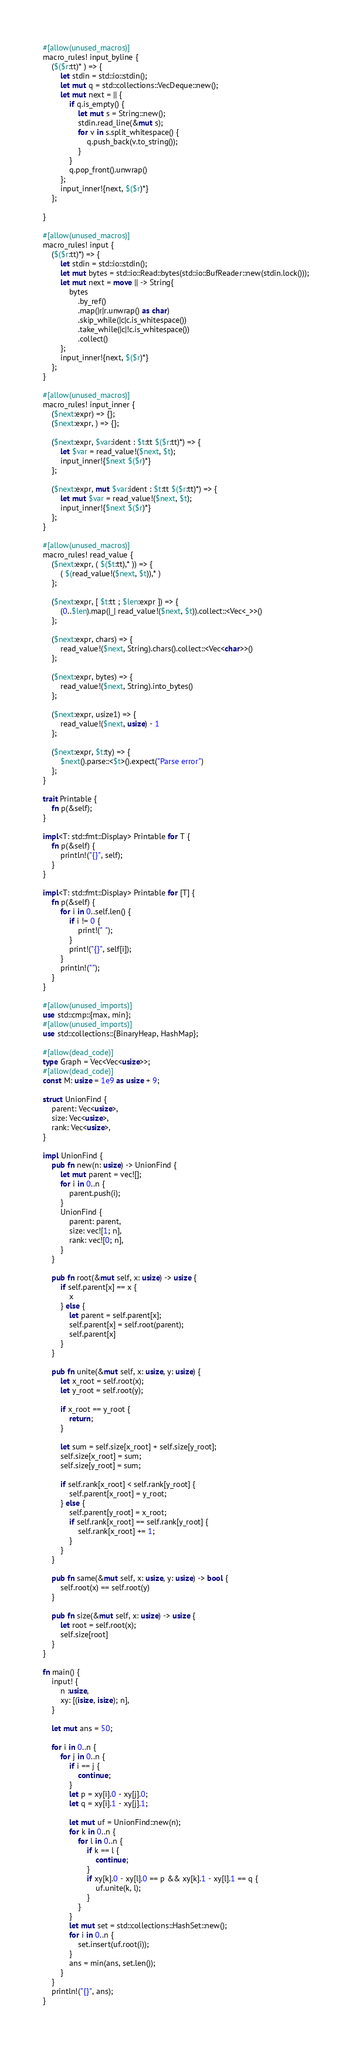<code> <loc_0><loc_0><loc_500><loc_500><_Rust_>#[allow(unused_macros)]
macro_rules! input_byline {
    ($($r:tt)* ) => {
        let stdin = std::io::stdin();
        let mut q = std::collections::VecDeque::new();
        let mut next = || {
            if q.is_empty() {
                let mut s = String::new();
                stdin.read_line(&mut s);
                for v in s.split_whitespace() {
                    q.push_back(v.to_string());
                }
            }
            q.pop_front().unwrap()
        };
        input_inner!{next, $($r)*}
    };

}

#[allow(unused_macros)]
macro_rules! input {
    ($($r:tt)*) => {
        let stdin = std::io::stdin();
        let mut bytes = std::io::Read::bytes(std::io::BufReader::new(stdin.lock()));
        let mut next = move || -> String{
            bytes
                .by_ref()
                .map(|r|r.unwrap() as char)
                .skip_while(|c|c.is_whitespace())
                .take_while(|c|!c.is_whitespace())
                .collect()
        };
        input_inner!{next, $($r)*}
    };
}

#[allow(unused_macros)]
macro_rules! input_inner {
    ($next:expr) => {};
    ($next:expr, ) => {};

    ($next:expr, $var:ident : $t:tt $($r:tt)*) => {
        let $var = read_value!($next, $t);
        input_inner!{$next $($r)*}
    };

    ($next:expr, mut $var:ident : $t:tt $($r:tt)*) => {
        let mut $var = read_value!($next, $t);
        input_inner!{$next $($r)*}
    };
}

#[allow(unused_macros)]
macro_rules! read_value {
    ($next:expr, ( $($t:tt),* )) => {
        ( $(read_value!($next, $t)),* )
    };

    ($next:expr, [ $t:tt ; $len:expr ]) => {
        (0..$len).map(|_| read_value!($next, $t)).collect::<Vec<_>>()
    };

    ($next:expr, chars) => {
        read_value!($next, String).chars().collect::<Vec<char>>()
    };

    ($next:expr, bytes) => {
        read_value!($next, String).into_bytes()
    };

    ($next:expr, usize1) => {
        read_value!($next, usize) - 1
    };

    ($next:expr, $t:ty) => {
        $next().parse::<$t>().expect("Parse error")
    };
}

trait Printable {
    fn p(&self);
}

impl<T: std::fmt::Display> Printable for T {
    fn p(&self) {
        println!("{}", self);
    }
}

impl<T: std::fmt::Display> Printable for [T] {
    fn p(&self) {
        for i in 0..self.len() {
            if i != 0 {
                print!(" ");
            }
            print!("{}", self[i]);
        }
        println!("");
    }
}

#[allow(unused_imports)]
use std::cmp::{max, min};
#[allow(unused_imports)]
use std::collections::{BinaryHeap, HashMap};

#[allow(dead_code)]
type Graph = Vec<Vec<usize>>;
#[allow(dead_code)]
const M: usize = 1e9 as usize + 9;

struct UnionFind {
    parent: Vec<usize>,
    size: Vec<usize>,
    rank: Vec<usize>,
}

impl UnionFind {
    pub fn new(n: usize) -> UnionFind {
        let mut parent = vec![];
        for i in 0..n {
            parent.push(i);
        }
        UnionFind {
            parent: parent,
            size: vec![1; n],
            rank: vec![0; n],
        }
    }

    pub fn root(&mut self, x: usize) -> usize {
        if self.parent[x] == x {
            x
        } else {
            let parent = self.parent[x];
            self.parent[x] = self.root(parent);
            self.parent[x]
        }
    }

    pub fn unite(&mut self, x: usize, y: usize) {
        let x_root = self.root(x);
        let y_root = self.root(y);

        if x_root == y_root {
            return;
        }

        let sum = self.size[x_root] + self.size[y_root];
        self.size[x_root] = sum;
        self.size[y_root] = sum;

        if self.rank[x_root] < self.rank[y_root] {
            self.parent[x_root] = y_root;
        } else {
            self.parent[y_root] = x_root;
            if self.rank[x_root] == self.rank[y_root] {
                self.rank[x_root] += 1;
            }
        }
    }

    pub fn same(&mut self, x: usize, y: usize) -> bool {
        self.root(x) == self.root(y)
    }

    pub fn size(&mut self, x: usize) -> usize {
        let root = self.root(x);
        self.size[root]
    }
}

fn main() {
    input! {
        n :usize,
        xy: [(isize, isize); n],
    }

    let mut ans = 50;

    for i in 0..n {
        for j in 0..n {
            if i == j {
                continue;
            }
            let p = xy[i].0 - xy[j].0;
            let q = xy[i].1 - xy[j].1;

            let mut uf = UnionFind::new(n);
            for k in 0..n {
                for l in 0..n {
                    if k == l {
                        continue;
                    }
                    if xy[k].0 - xy[l].0 == p && xy[k].1 - xy[l].1 == q {
                        uf.unite(k, l);
                    }
                }
            }
            let mut set = std::collections::HashSet::new();
            for i in 0..n {
                set.insert(uf.root(i));
            }
            ans = min(ans, set.len());
        }
    }
    println!("{}", ans);
}
</code> 